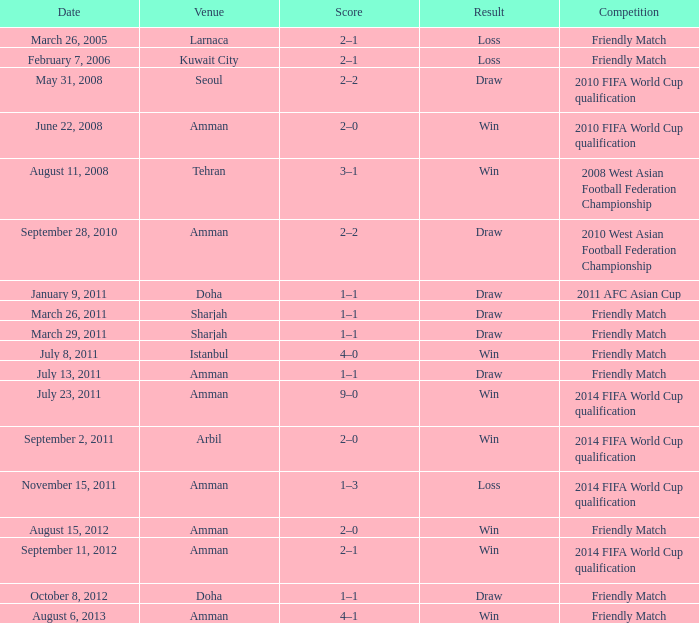Parse the full table. {'header': ['Date', 'Venue', 'Score', 'Result', 'Competition'], 'rows': [['March 26, 2005', 'Larnaca', '2–1', 'Loss', 'Friendly Match'], ['February 7, 2006', 'Kuwait City', '2–1', 'Loss', 'Friendly Match'], ['May 31, 2008', 'Seoul', '2–2', 'Draw', '2010 FIFA World Cup qualification'], ['June 22, 2008', 'Amman', '2–0', 'Win', '2010 FIFA World Cup qualification'], ['August 11, 2008', 'Tehran', '3–1', 'Win', '2008 West Asian Football Federation Championship'], ['September 28, 2010', 'Amman', '2–2', 'Draw', '2010 West Asian Football Federation Championship'], ['January 9, 2011', 'Doha', '1–1', 'Draw', '2011 AFC Asian Cup'], ['March 26, 2011', 'Sharjah', '1–1', 'Draw', 'Friendly Match'], ['March 29, 2011', 'Sharjah', '1–1', 'Draw', 'Friendly Match'], ['July 8, 2011', 'Istanbul', '4–0', 'Win', 'Friendly Match'], ['July 13, 2011', 'Amman', '1–1', 'Draw', 'Friendly Match'], ['July 23, 2011', 'Amman', '9–0', 'Win', '2014 FIFA World Cup qualification'], ['September 2, 2011', 'Arbil', '2–0', 'Win', '2014 FIFA World Cup qualification'], ['November 15, 2011', 'Amman', '1–3', 'Loss', '2014 FIFA World Cup qualification'], ['August 15, 2012', 'Amman', '2–0', 'Win', 'Friendly Match'], ['September 11, 2012', 'Amman', '2–1', 'Win', '2014 FIFA World Cup qualification'], ['October 8, 2012', 'Doha', '1–1', 'Draw', 'Friendly Match'], ['August 6, 2013', 'Amman', '4–1', 'Win', 'Friendly Match']]} What was the outcome of the friendly game that took place on october 8, 2012? Draw. 